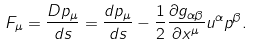<formula> <loc_0><loc_0><loc_500><loc_500>F _ { \mu } = \frac { D p _ { \mu } } { d s } = \frac { d p _ { \mu } } { d s } - \frac { 1 } { 2 } \frac { \partial g _ { \alpha \beta } } { \partial x ^ { \mu } } u ^ { \alpha } p ^ { \beta } .</formula> 